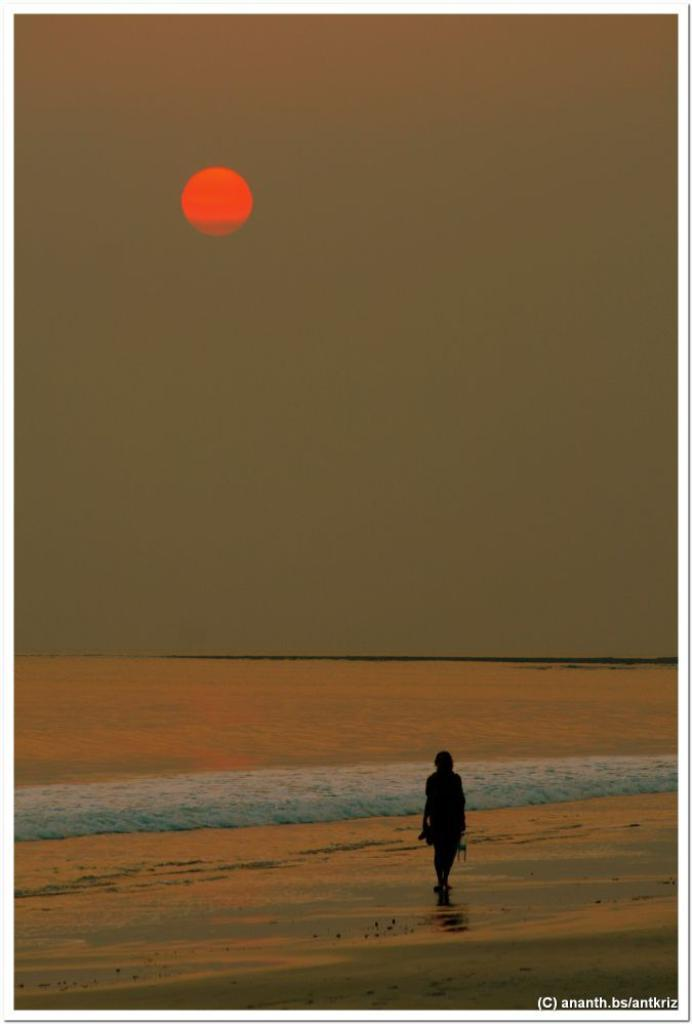What is the main subject of the photo in the image? There is a person in the photo. What type of border is around the photo? The photo has a border in the image. What natural feature can be seen in the background of the photo? The ocean is visible in the image. What celestial body is observable in the sky? The sun is observable in the sky. What brand of toothpaste is being advertised in the photo? There is no toothpaste or advertisement present in the image. Can you tell if the person in the photo is coughing? There is no indication of the person coughing in the image. 